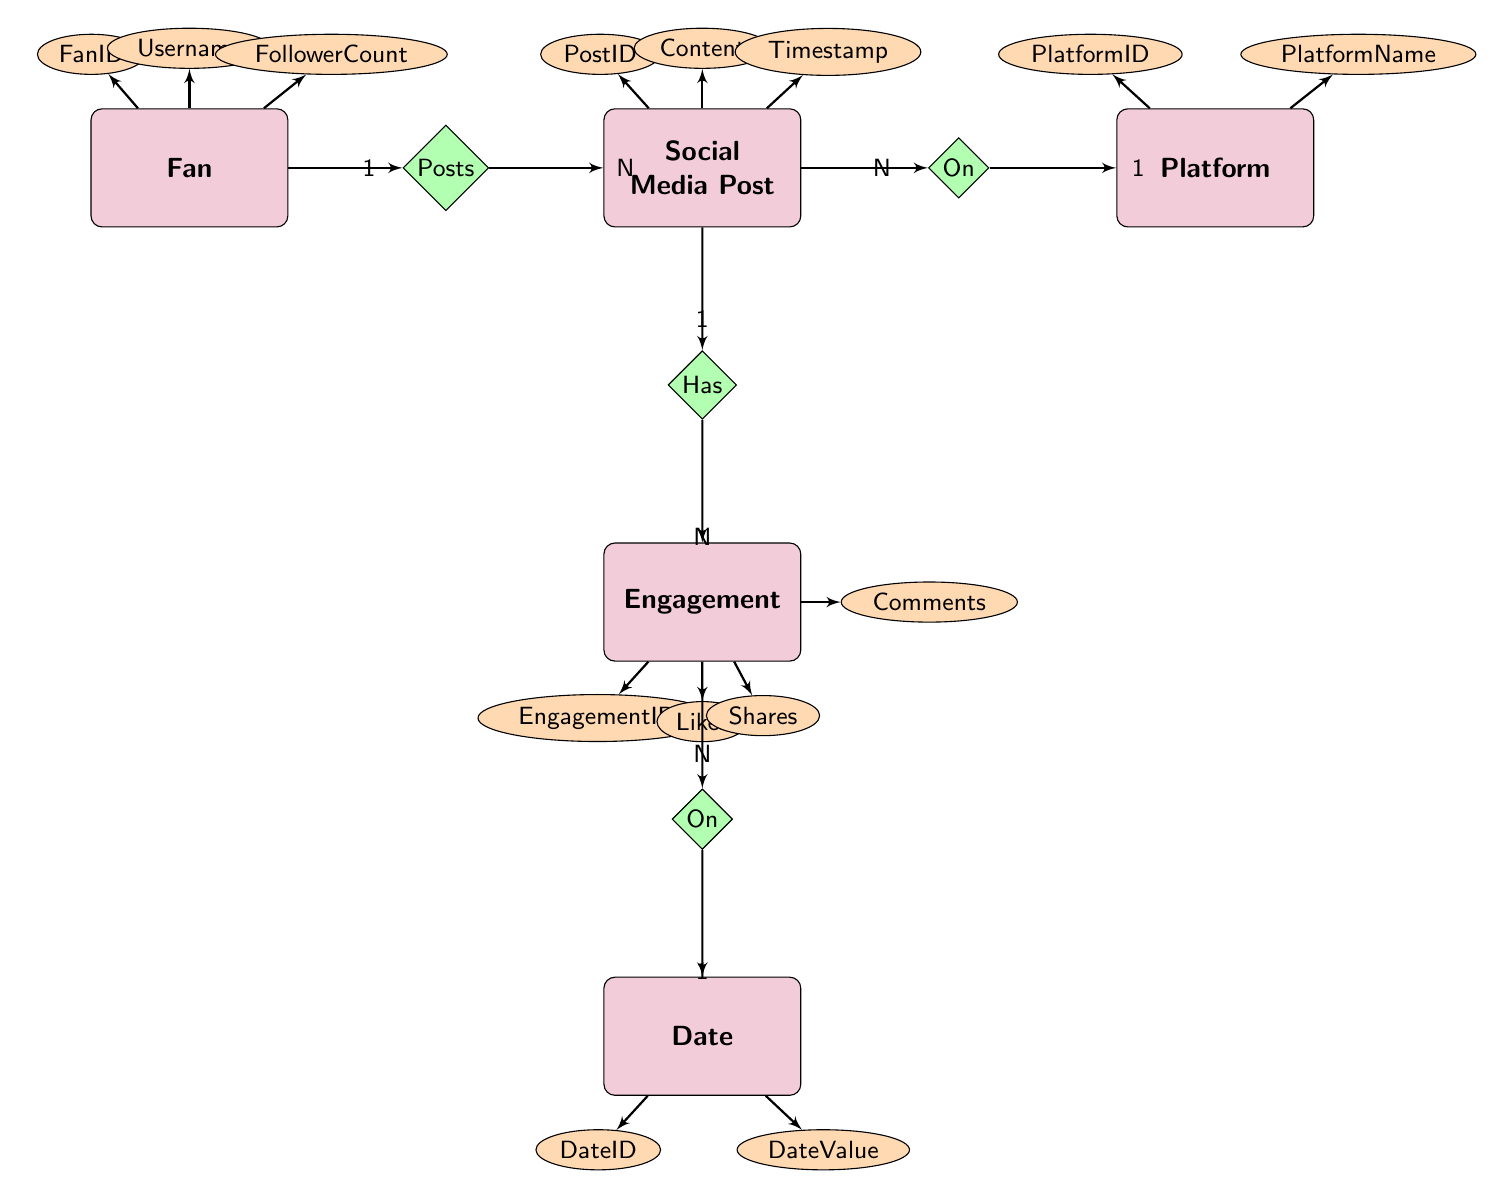what are the attributes of the Fan entity? The attributes of the Fan entity are listed directly under it in the diagram. They include FanID, Username, and FollowerCount.
Answer: FanID, Username, FollowerCount how many edges originate from SocialMediaPost? To determine the number of edges originating from SocialMediaPost, we can count the relationships directly connected to it. There are three relationships: Posts (to Fan), On (to Platform), and Has (to Engagement).
Answer: 3 what is the relationship between Engagement and Date? The relationship between Engagement and Date is denoted in the diagram by the "On" relationship. The diagram indicates that Engagement has a direct connection to Date.
Answer: On which entity has the attribute Likes? The entity that has the attribute Likes is Engagement. This is shown by the direct connection from Engagement to the Likes attribute in the diagram.
Answer: Engagement how many entities are in the diagram? To find the number of entities, we can count how many distinct entities are labeled in the diagram. There are five entities: Fan, SocialMediaPost, Platform, Engagement, and Date.
Answer: 5 what is the cardinality between Fan and SocialMediaPost? The cardinality between Fan and SocialMediaPost is indicated in the diagram with a "1" next to Fan and an "N" next to SocialMediaPost, which means one Fan can create multiple SocialMediaPosts.
Answer: 1 to N what are the attributes of the Engagement entity? The attributes of the Engagement entity are listed directly below it in the diagram. They include EngagementID, Likes, Shares, and Comments.
Answer: EngagementID, Likes, Shares, Comments how many platforms can a SocialMediaPost be associated with? The diagram shows a many-to-one relationship from SocialMediaPost to Platform, which indicates that each SocialMediaPost can be associated with one or many Platforms, but specifically only one Platform at a time.
Answer: N what entity is connected to Date through Engagement? The entity that is connected to Date through Engagement is Engagement itself. The relationship "On" connects Engagement to Date in the diagram.
Answer: Engagement 